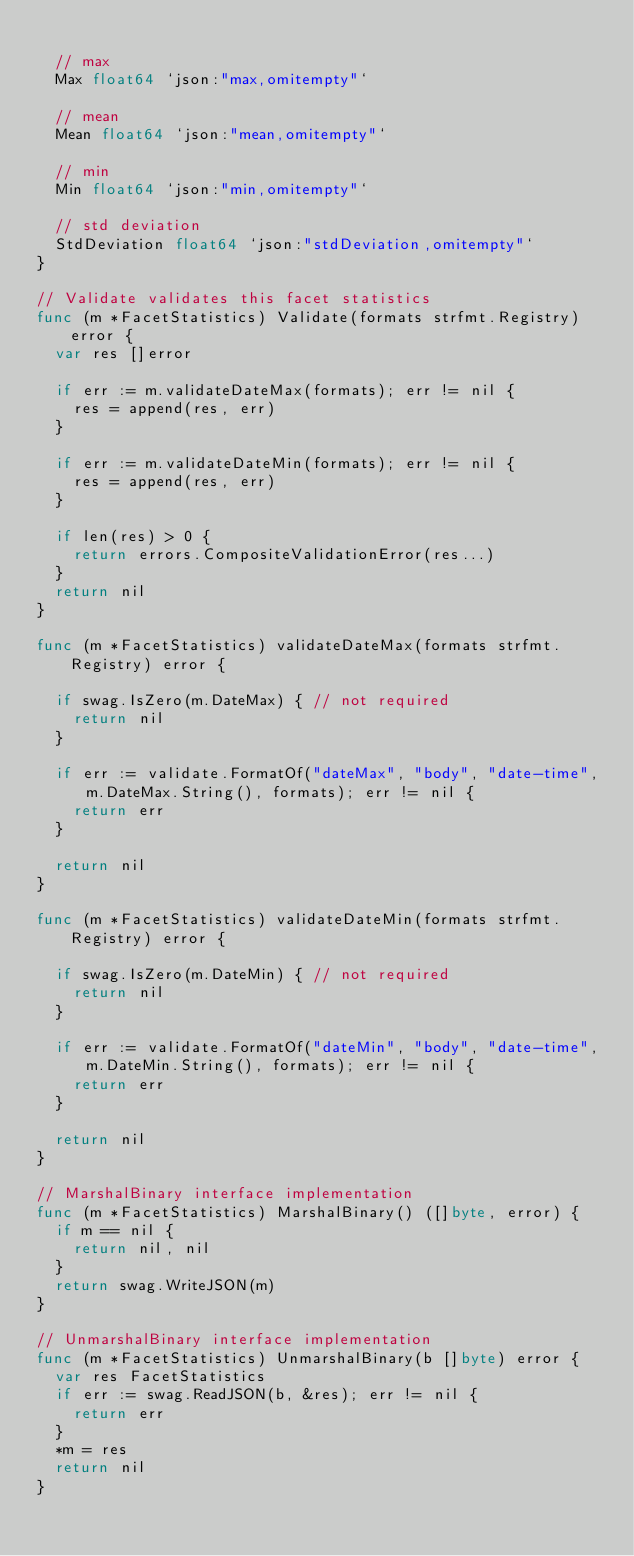<code> <loc_0><loc_0><loc_500><loc_500><_Go_>
	// max
	Max float64 `json:"max,omitempty"`

	// mean
	Mean float64 `json:"mean,omitempty"`

	// min
	Min float64 `json:"min,omitempty"`

	// std deviation
	StdDeviation float64 `json:"stdDeviation,omitempty"`
}

// Validate validates this facet statistics
func (m *FacetStatistics) Validate(formats strfmt.Registry) error {
	var res []error

	if err := m.validateDateMax(formats); err != nil {
		res = append(res, err)
	}

	if err := m.validateDateMin(formats); err != nil {
		res = append(res, err)
	}

	if len(res) > 0 {
		return errors.CompositeValidationError(res...)
	}
	return nil
}

func (m *FacetStatistics) validateDateMax(formats strfmt.Registry) error {

	if swag.IsZero(m.DateMax) { // not required
		return nil
	}

	if err := validate.FormatOf("dateMax", "body", "date-time", m.DateMax.String(), formats); err != nil {
		return err
	}

	return nil
}

func (m *FacetStatistics) validateDateMin(formats strfmt.Registry) error {

	if swag.IsZero(m.DateMin) { // not required
		return nil
	}

	if err := validate.FormatOf("dateMin", "body", "date-time", m.DateMin.String(), formats); err != nil {
		return err
	}

	return nil
}

// MarshalBinary interface implementation
func (m *FacetStatistics) MarshalBinary() ([]byte, error) {
	if m == nil {
		return nil, nil
	}
	return swag.WriteJSON(m)
}

// UnmarshalBinary interface implementation
func (m *FacetStatistics) UnmarshalBinary(b []byte) error {
	var res FacetStatistics
	if err := swag.ReadJSON(b, &res); err != nil {
		return err
	}
	*m = res
	return nil
}
</code> 